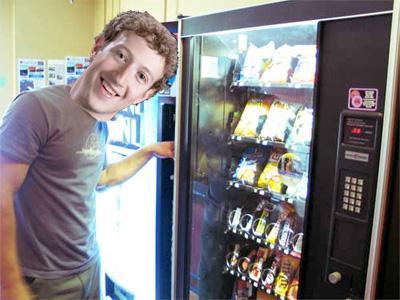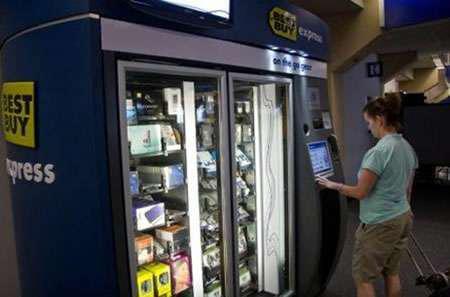The first image is the image on the left, the second image is the image on the right. Evaluate the accuracy of this statement regarding the images: "Someone is touching a vending machine in the right image.". Is it true? Answer yes or no. Yes. The first image is the image on the left, the second image is the image on the right. Assess this claim about the two images: "Two people are shown at vending machines.". Correct or not? Answer yes or no. Yes. 